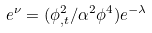Convert formula to latex. <formula><loc_0><loc_0><loc_500><loc_500>e ^ { \nu } = ( \phi ^ { 2 } _ { , t } / \alpha ^ { 2 } \phi ^ { 4 } ) e ^ { - \lambda }</formula> 